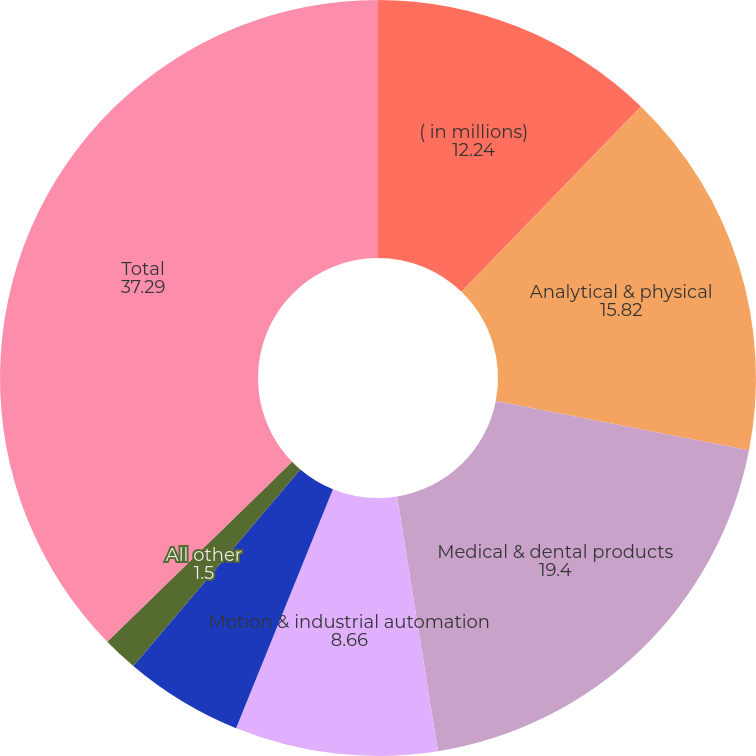Convert chart. <chart><loc_0><loc_0><loc_500><loc_500><pie_chart><fcel>( in millions)<fcel>Analytical & physical<fcel>Medical & dental products<fcel>Motion & industrial automation<fcel>Product identification<fcel>All other<fcel>Total<nl><fcel>12.24%<fcel>15.82%<fcel>19.4%<fcel>8.66%<fcel>5.08%<fcel>1.5%<fcel>37.29%<nl></chart> 